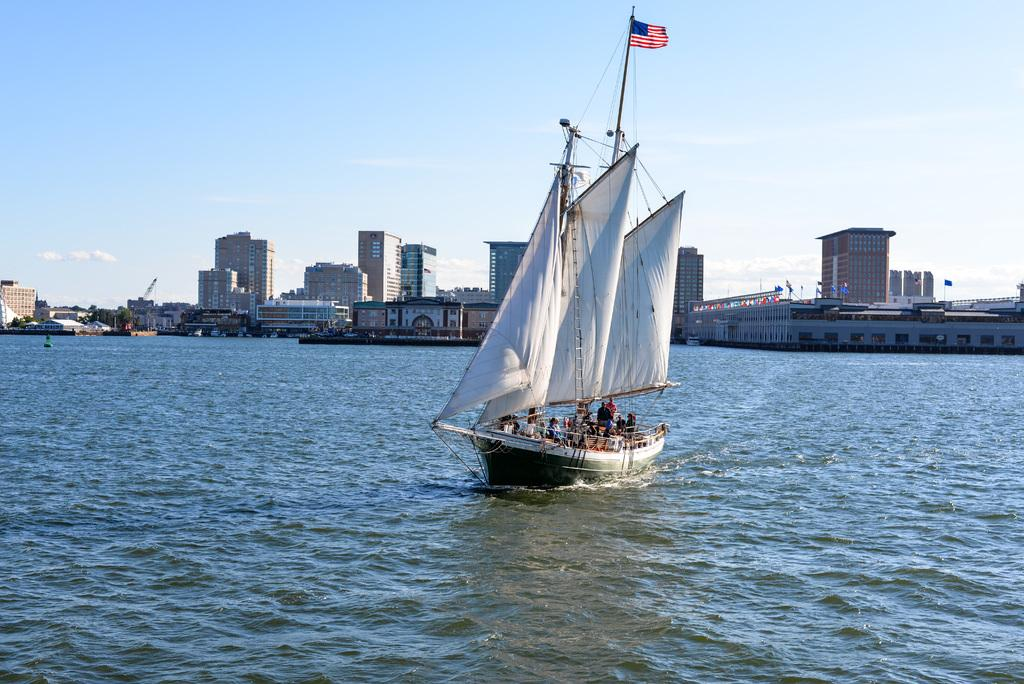What is the main subject of the image? The main subject of the image is a boat carrying people in the water. What else can be seen in the image besides the boat? There are buildings, trees, and flag poles visible in the image. How would you describe the sky in the image? The sky is blue and cloudy in the image. What type of stitch is being used to sew the flag on the flag pole? There is no indication of a stitch or any sewing activity in the image, as it features a boat carrying people in the water, buildings, trees, and flag poles. --- Facts: 1. There is a person holding a camera in the image. 2. The person is standing on a bridge. 3. There is a river below the bridge. 4. There are trees on both sides of the river. 5. The sky is visible in the image. Absurd Topics: dance, piano, book Conversation: What is the person in the image doing? The person in the image is holding a camera. Where is the person standing in the image? The person is standing on a bridge. What can be seen below the bridge in the image? There is a river below the bridge. What type of vegetation is present on both sides of the river? There are trees on both sides of the river. What is visible in the sky in the image? The sky is visible in the image. Reasoning: Let's think step by step in order to produce the conversation. We start by identifying the main subject of the image, which is the person holding a camera. Then, we describe the person's location, which is on a bridge. Next, we mention the river below the bridge and the trees on both sides of the river. Finally, we acknowledge the presence of the sky in the image. Absurd Question/Answer: What type of dance is the person performing on the bridge in the image? There is no indication of a dance or any dancing activity in the image, as it features a person holding a camera on a bridge, with a river, trees, and the sky visible. --- Facts: 1. There is a group of people sitting on the grass. 2. The people are holding musical instruments. 3. There is a stage in the background. 4. There are trees in the background. 5. The sky is visible in the image. Absurd Topics: car, computer, painting Conversation: What are the people in the image doing? The people in the image are sitting on the grass and holding musical instruments. What can be seen in the background of the image? There is a stage and trees in the background. What is visible in the sky in the image? The sky is visible in the image. Reasoning: Let's think step by step in order to 